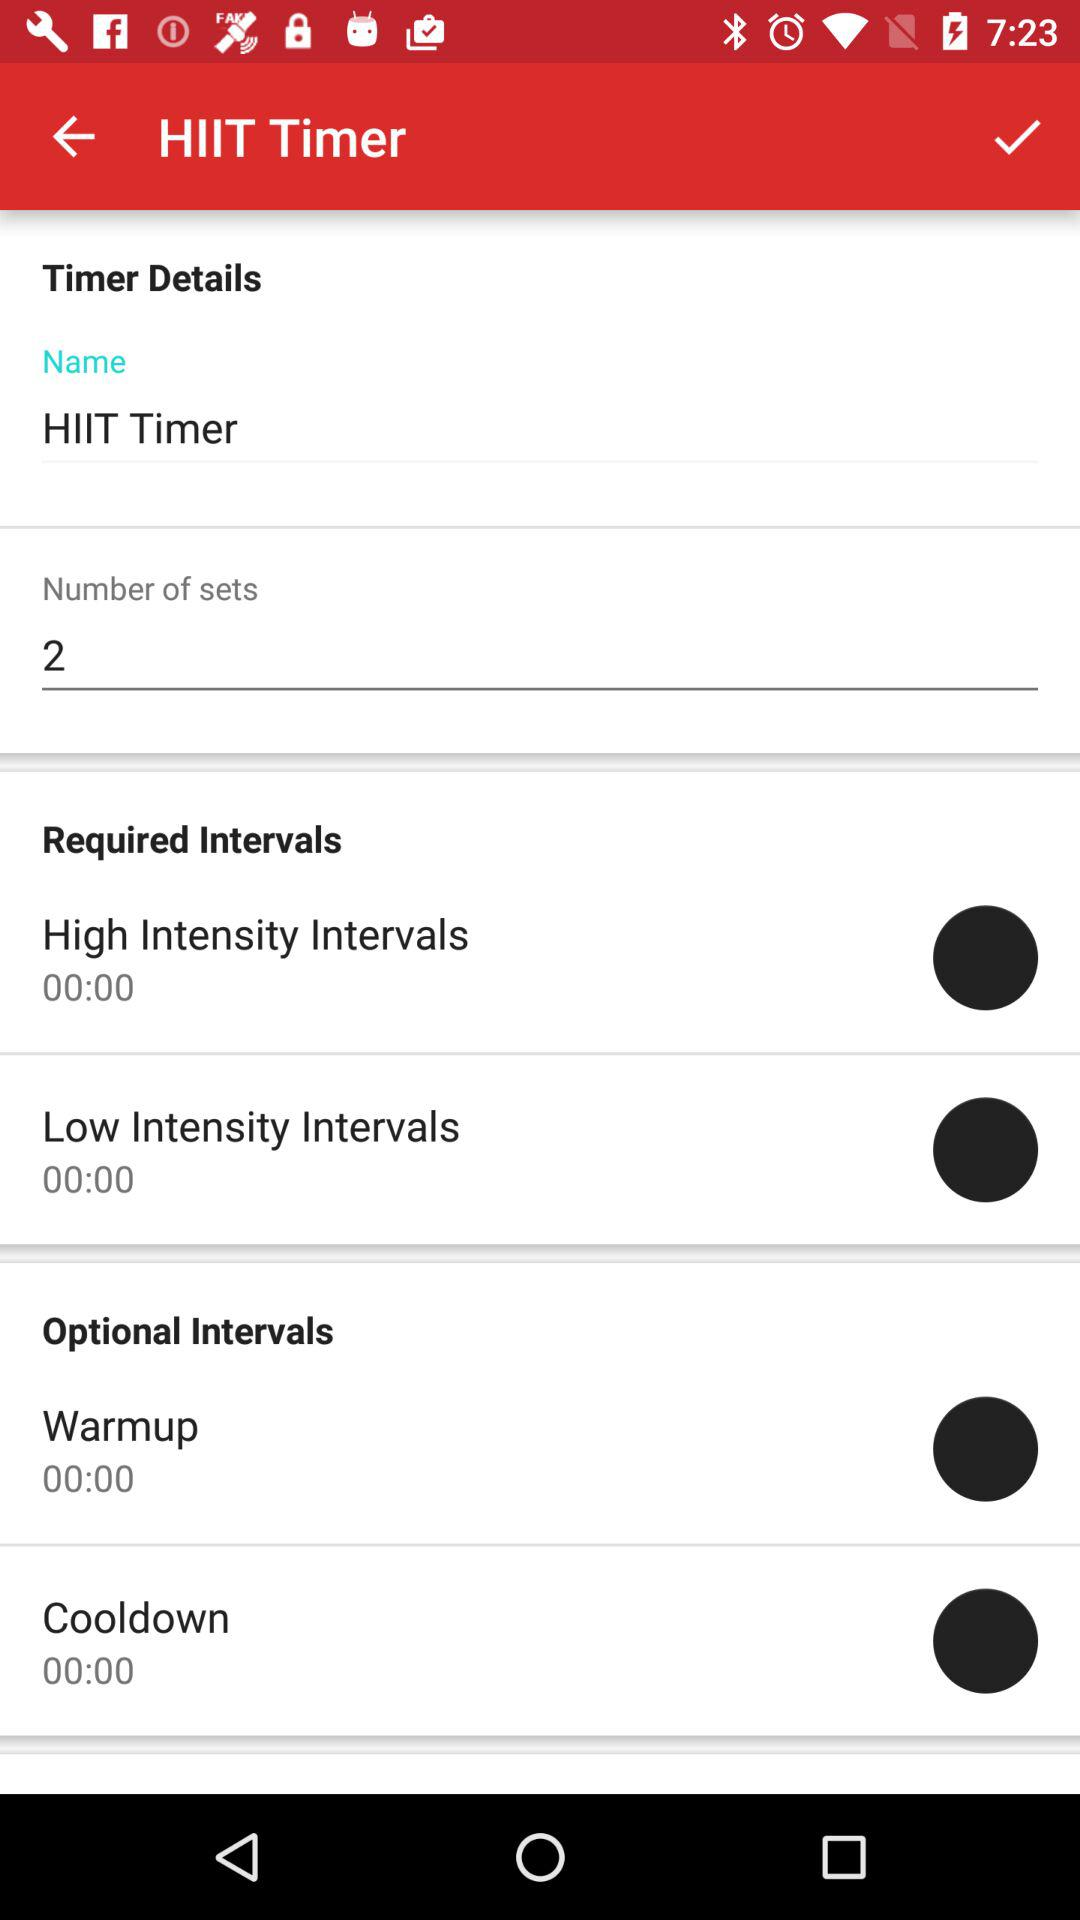What are the options given at required intervals? The options are "High Intensity Intervals" and "Low Intensity Intervals". 